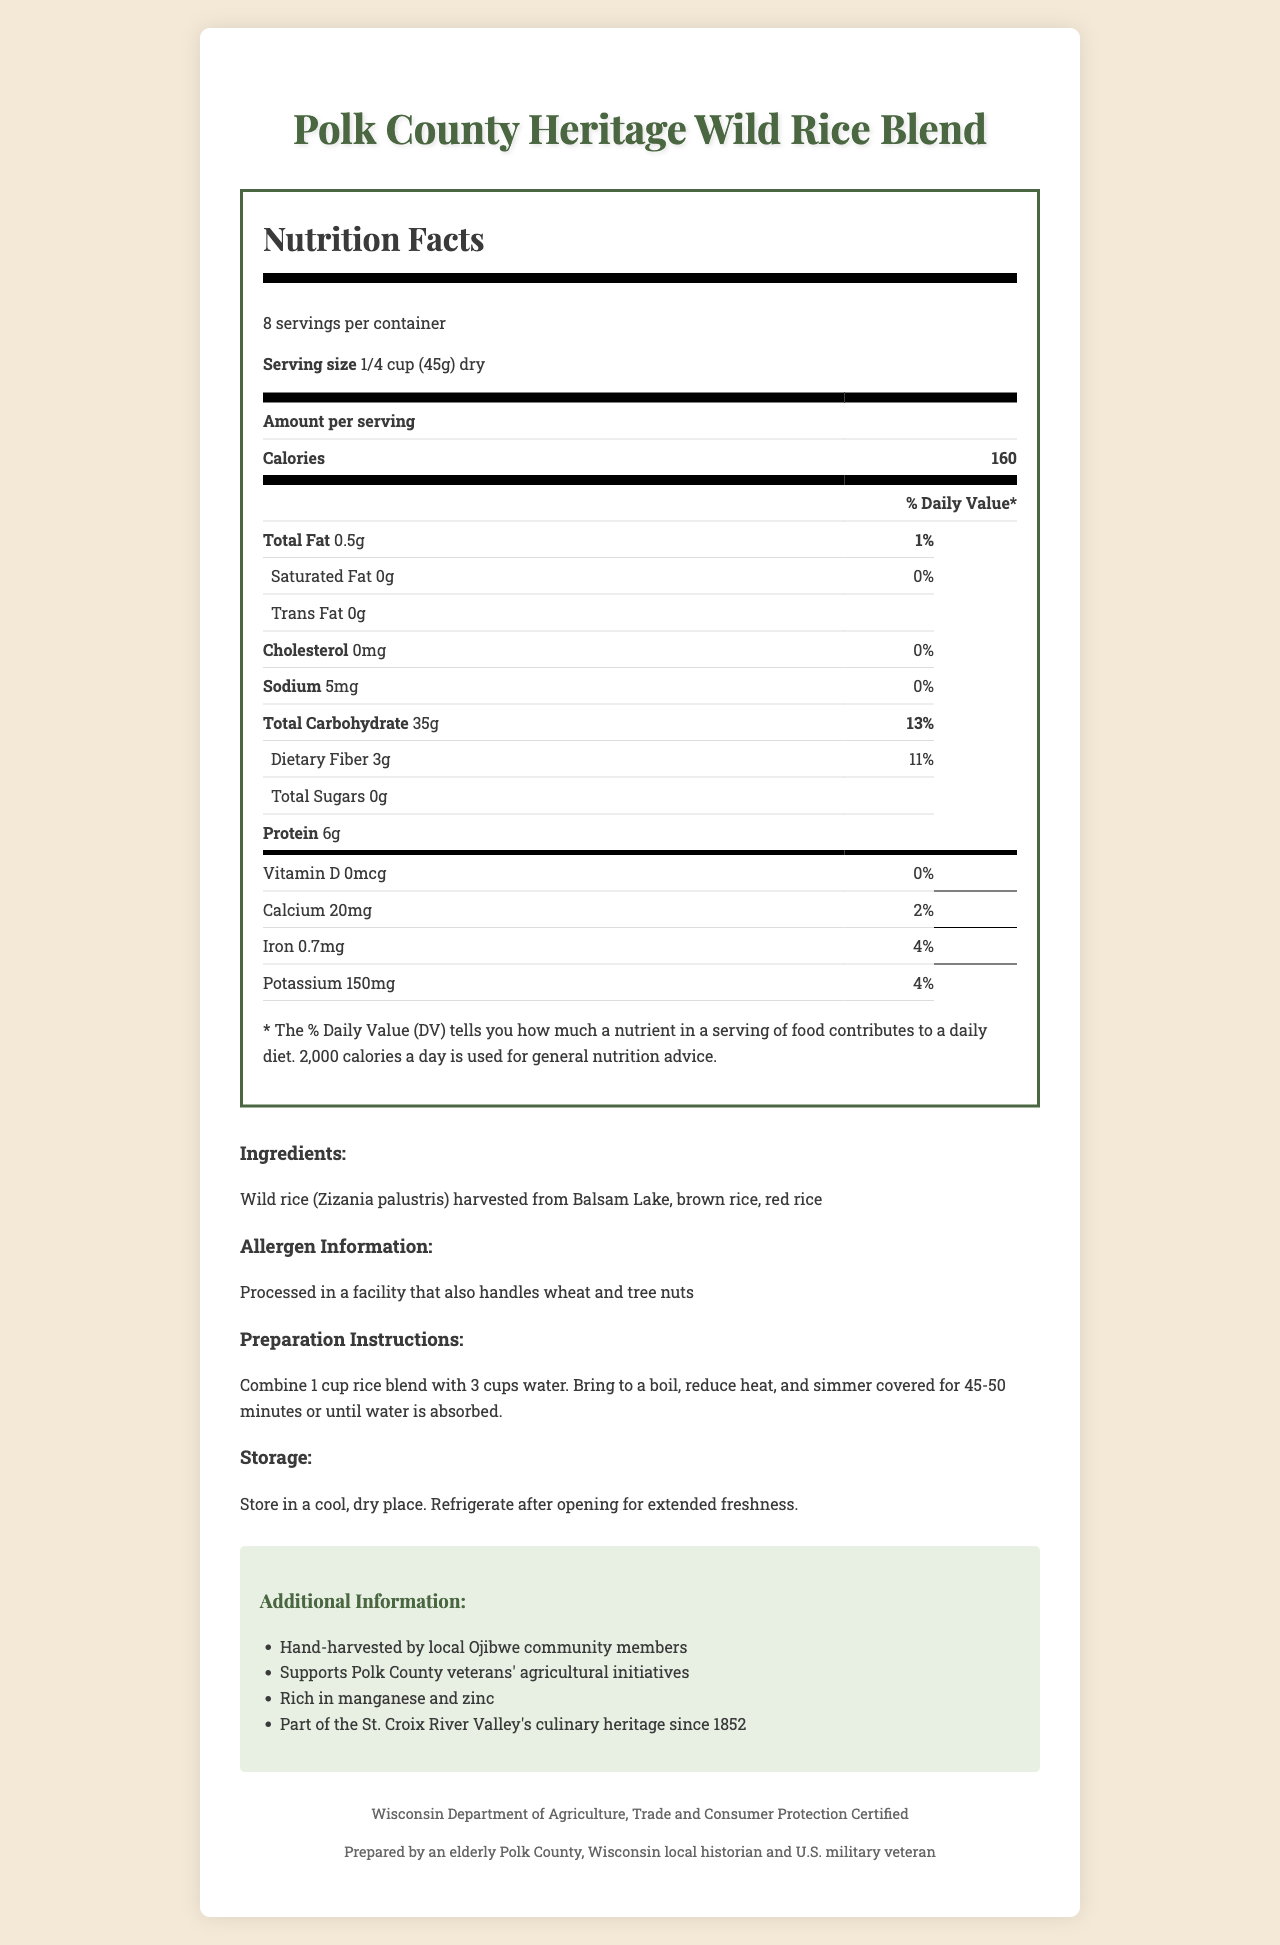what is the serving size? The serving size is listed at the beginning of the Nutrition Facts section as "1/4 cup (45g) dry."
Answer: 1/4 cup (45g) dry how many servings are in one container? The number of servings per container is mentioned right under the serving size as "8 servings per container."
Answer: 8 how much fiber is in one serving? The amount of dietary fiber per serving is shown under the Total Carbohydrate section as "Dietary Fiber 3g."
Answer: 3g what is the percentage of daily value for dietary fiber? The % Daily Value for dietary fiber is displayed next to the amount of fiber as "11%."
Answer: 11% what are the main ingredients? The main ingredients are listed under the Ingredients section as "Wild rice (Zizania palustris) harvested from Balsam Lake, brown rice, red rice."
Answer: Wild rice (Zizania palustris) harvested from Balsam Lake, brown rice, red rice where is the wild rice harvested from? A. Green Lake B. Balsam Lake C. Mill Pond The wild rice is specifically noted to be harvested from Balsam Lake in the Ingredients section.
Answer: B how much protein is in one serving? A. 5g B. 6g C. 7g The protein content per serving is listed as "6g" in the Nutrition Facts table.
Answer: B is there any cholesterol in this rice blend? The Nutrition Facts section lists cholesterol content as "0mg," with a daily value of "0%."
Answer: No is this product certified by any authority? The footer of the document indicates certification as "Wisconsin Department of Agriculture, Trade and Consumer Protection Certified."
Answer: Yes provide a brief summary of the entire document The summary outlines the key sections and content of the document, covering the Nutrition Facts, ingredients, allergen information, preparation instructions, storage advice, additional information, and certification.
Answer: The document provides the Nutrition Facts for Polk County Heritage Wild Rice Blend. It includes information like serving size, servings per container, calories, and detailed nutrient content (including dietary fiber, protein, and others). Additionally, it lists the main ingredients, allergen information, preparation instructions, storage advice, and extra qualifications like local harvest and community support. The product is certified by a Wisconsin authority. what is the cooking time for the rice blend? The preparation instructions indicate that the rice blend should be simmered covered for 45-50 minutes or until water is absorbed.
Answer: 45-50 minutes which nutrients are mentioned to be particularly rich in this rice blend? The Additional Information section specifically mentions that the rice blend is rich in manganese and zinc.
Answer: Manganese and zinc what kind of community is involved in harvesting the wild rice? The Additional Information section mentions that the wild rice is hand-harvested by local Ojibwe community members.
Answer: Ojibwe community members what is the total carbohydrate content per serving? The Nutrition Facts section lists the total carbohydrate content as "35g."
Answer: 35g how many calories are there in one serving of this wild rice blend? The number of calories per serving is prominently displayed in the Nutrition Facts section as "160."
Answer: 160 can the exact amount of manganese be found in the document? The document states that the rice blend is rich in manganese but does not provide the exact amount.
Answer: Not enough information 